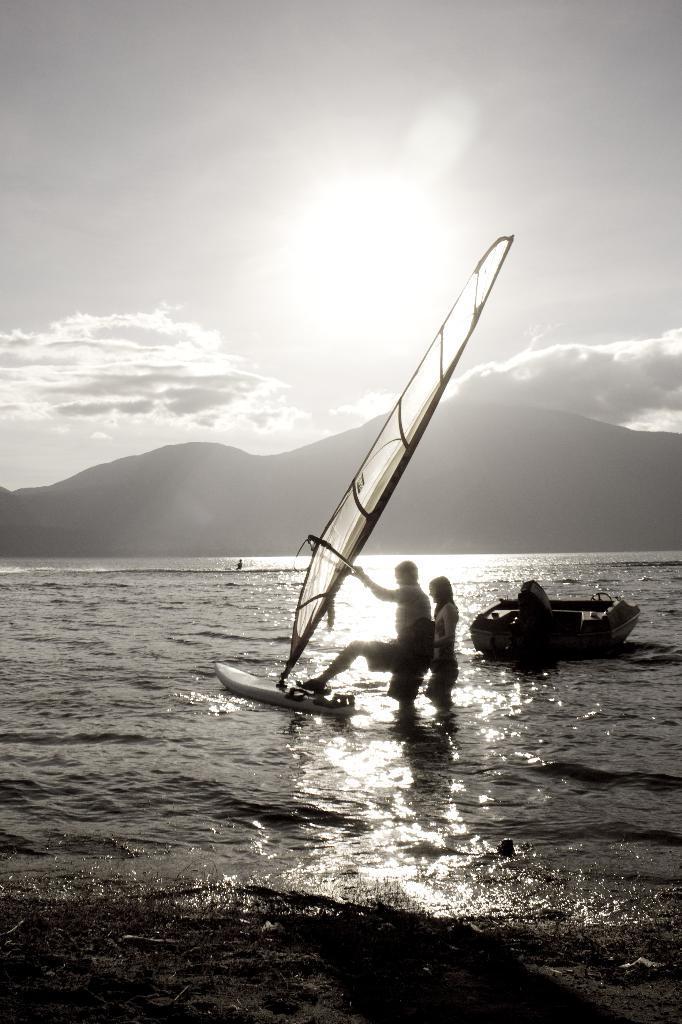Please provide a concise description of this image. It is the black and white image in which there is a couple standing in the water by holding the mast which is in the boat. At the top there is the sky. In the background there are hills. On the right side there is a motor boat in the water. 